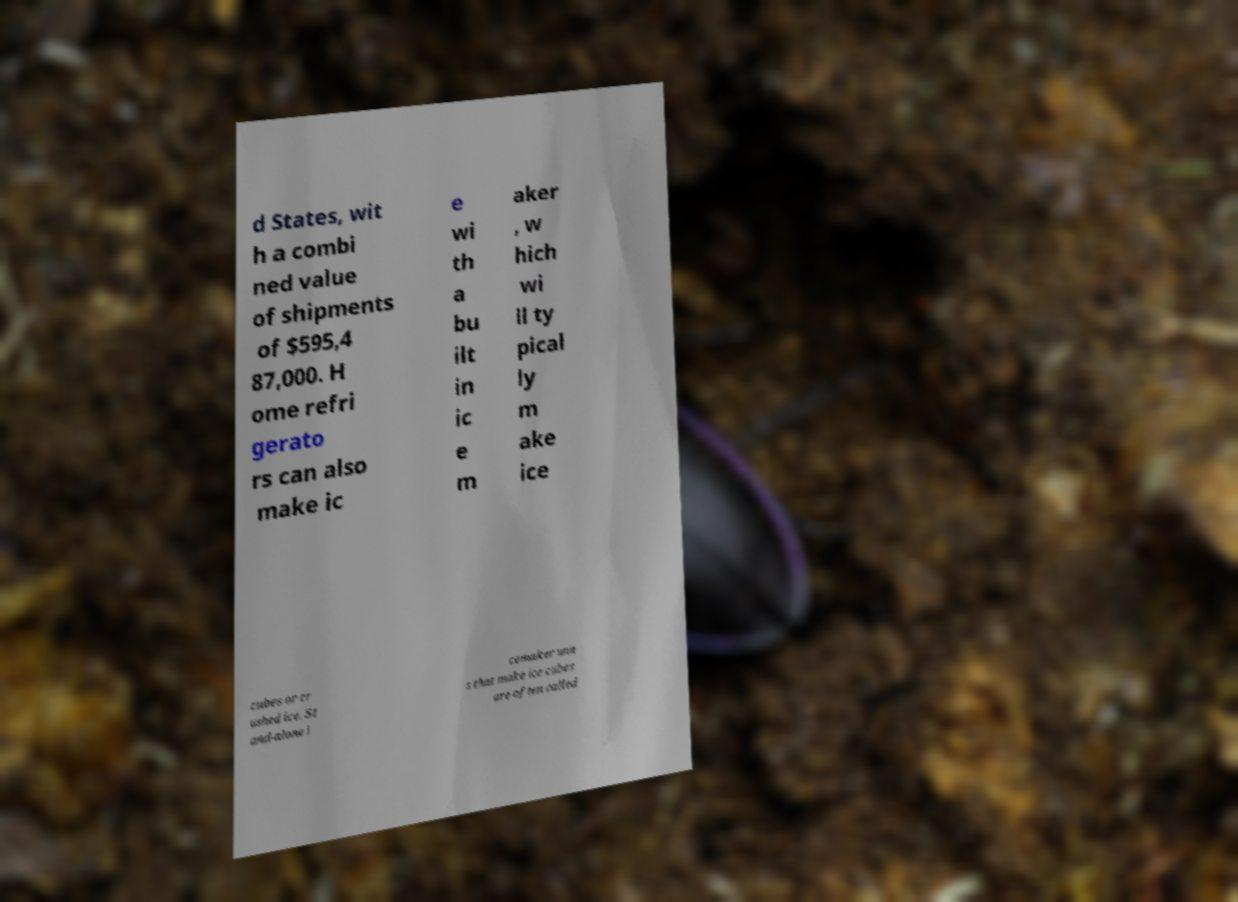I need the written content from this picture converted into text. Can you do that? d States, wit h a combi ned value of shipments of $595,4 87,000. H ome refri gerato rs can also make ic e wi th a bu ilt in ic e m aker , w hich wi ll ty pical ly m ake ice cubes or cr ushed ice. St and-alone i cemaker unit s that make ice cubes are often called 